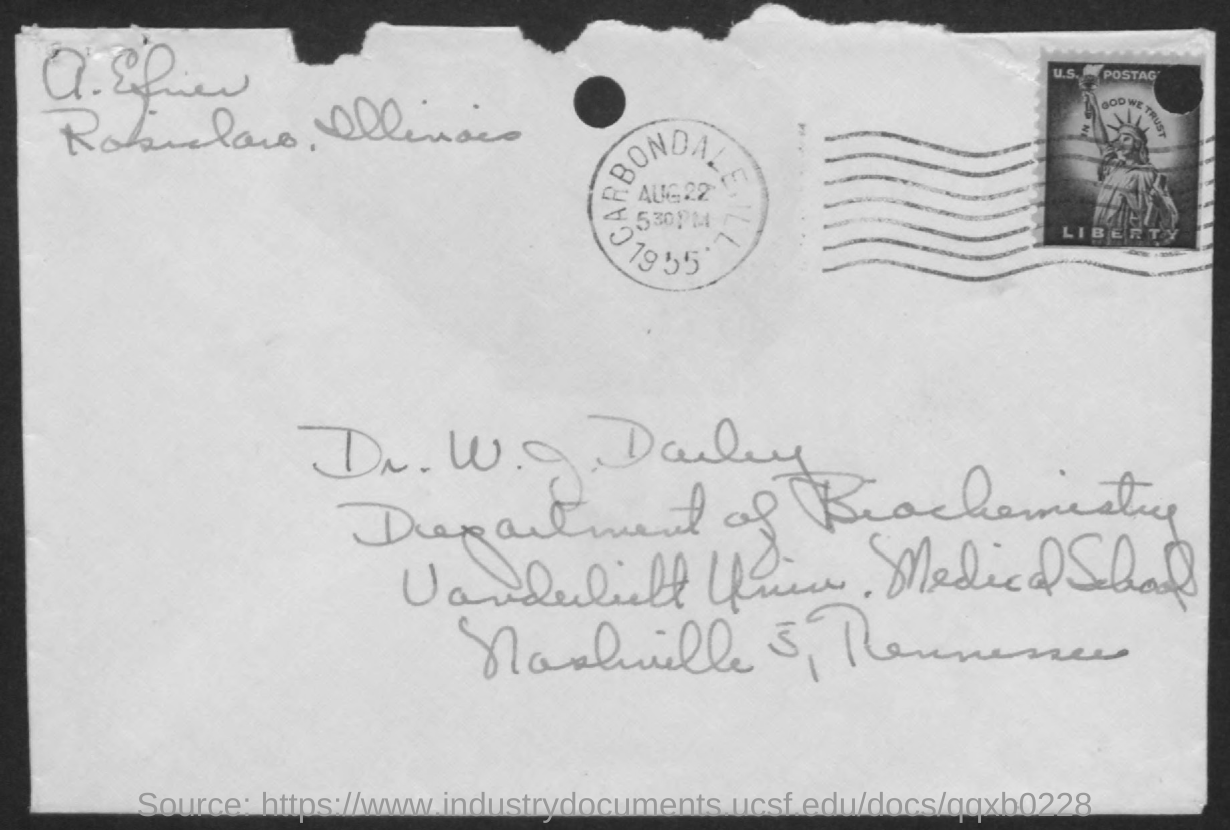Draw attention to some important aspects in this diagram. Dr. W.J. Darby is affiliated with the Department of Biochemistry. The seal mentions the year 1955. The phrase 'In God We Trust' is written above the image. The date indicated on the seal is August 22nd. The image below contains the word 'Liberty.' 